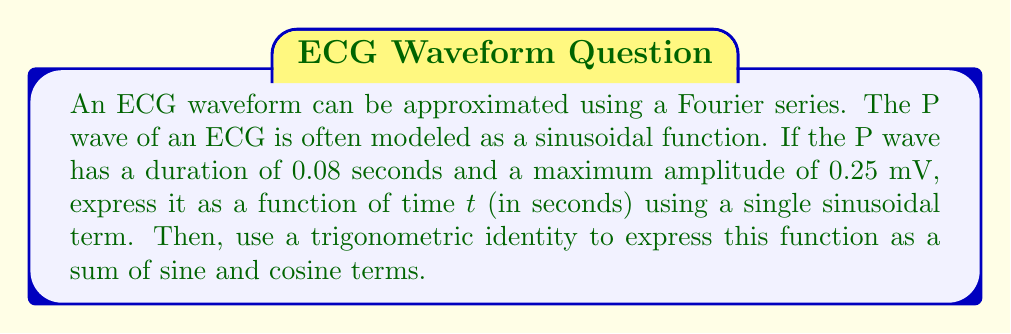Can you solve this math problem? 1) First, let's model the P wave as a sinusoidal function:

   $$f(t) = A \sin(\omega t)$$

   where A is the amplitude and $\omega$ is the angular frequency.

2) We know:
   - Amplitude (A) = 0.25 mV
   - Duration = 0.08 s, which corresponds to half a period

3) Calculate $\omega$:
   $$\frac{T}{2} = 0.08 \text{ s}$$
   $$T = 0.16 \text{ s}$$
   $$\omega = \frac{2\pi}{T} = \frac{2\pi}{0.16} = 39.27 \text{ rad/s}$$

4) The P wave function:
   $$f(t) = 0.25 \sin(39.27t)$$

5) To express this as a sum of sine and cosine terms, we can use the trigonometric identity:
   $$\sin(A) = \sin(A)\cos(0) + \cos(A)\sin(0)$$

6) Applying this identity to our function:
   $$f(t) = 0.25 [\sin(39.27t)\cos(0) + \cos(39.27t)\sin(0)]$$

7) Simplify:
   $$f(t) = 0.25 \sin(39.27t) + 0$$

Therefore, the function expressed as a sum of sine and cosine terms is the same as the original function in this case.
Answer: $f(t) = 0.25 \sin(39.27t)$ 